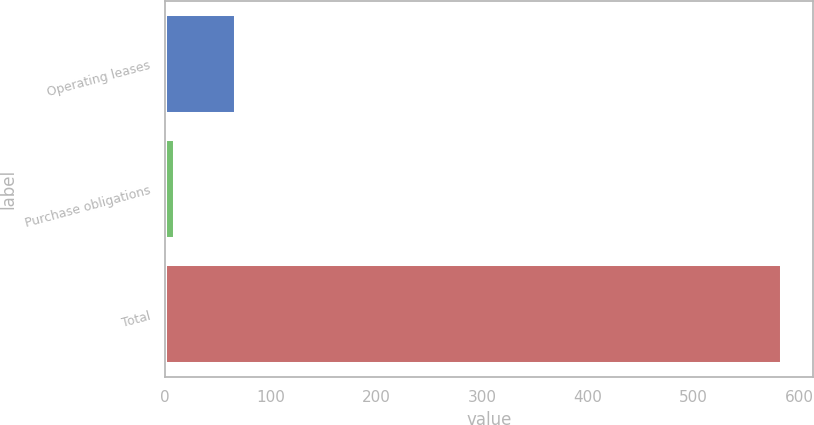<chart> <loc_0><loc_0><loc_500><loc_500><bar_chart><fcel>Operating leases<fcel>Purchase obligations<fcel>Total<nl><fcel>67.4<fcel>10<fcel>584<nl></chart> 